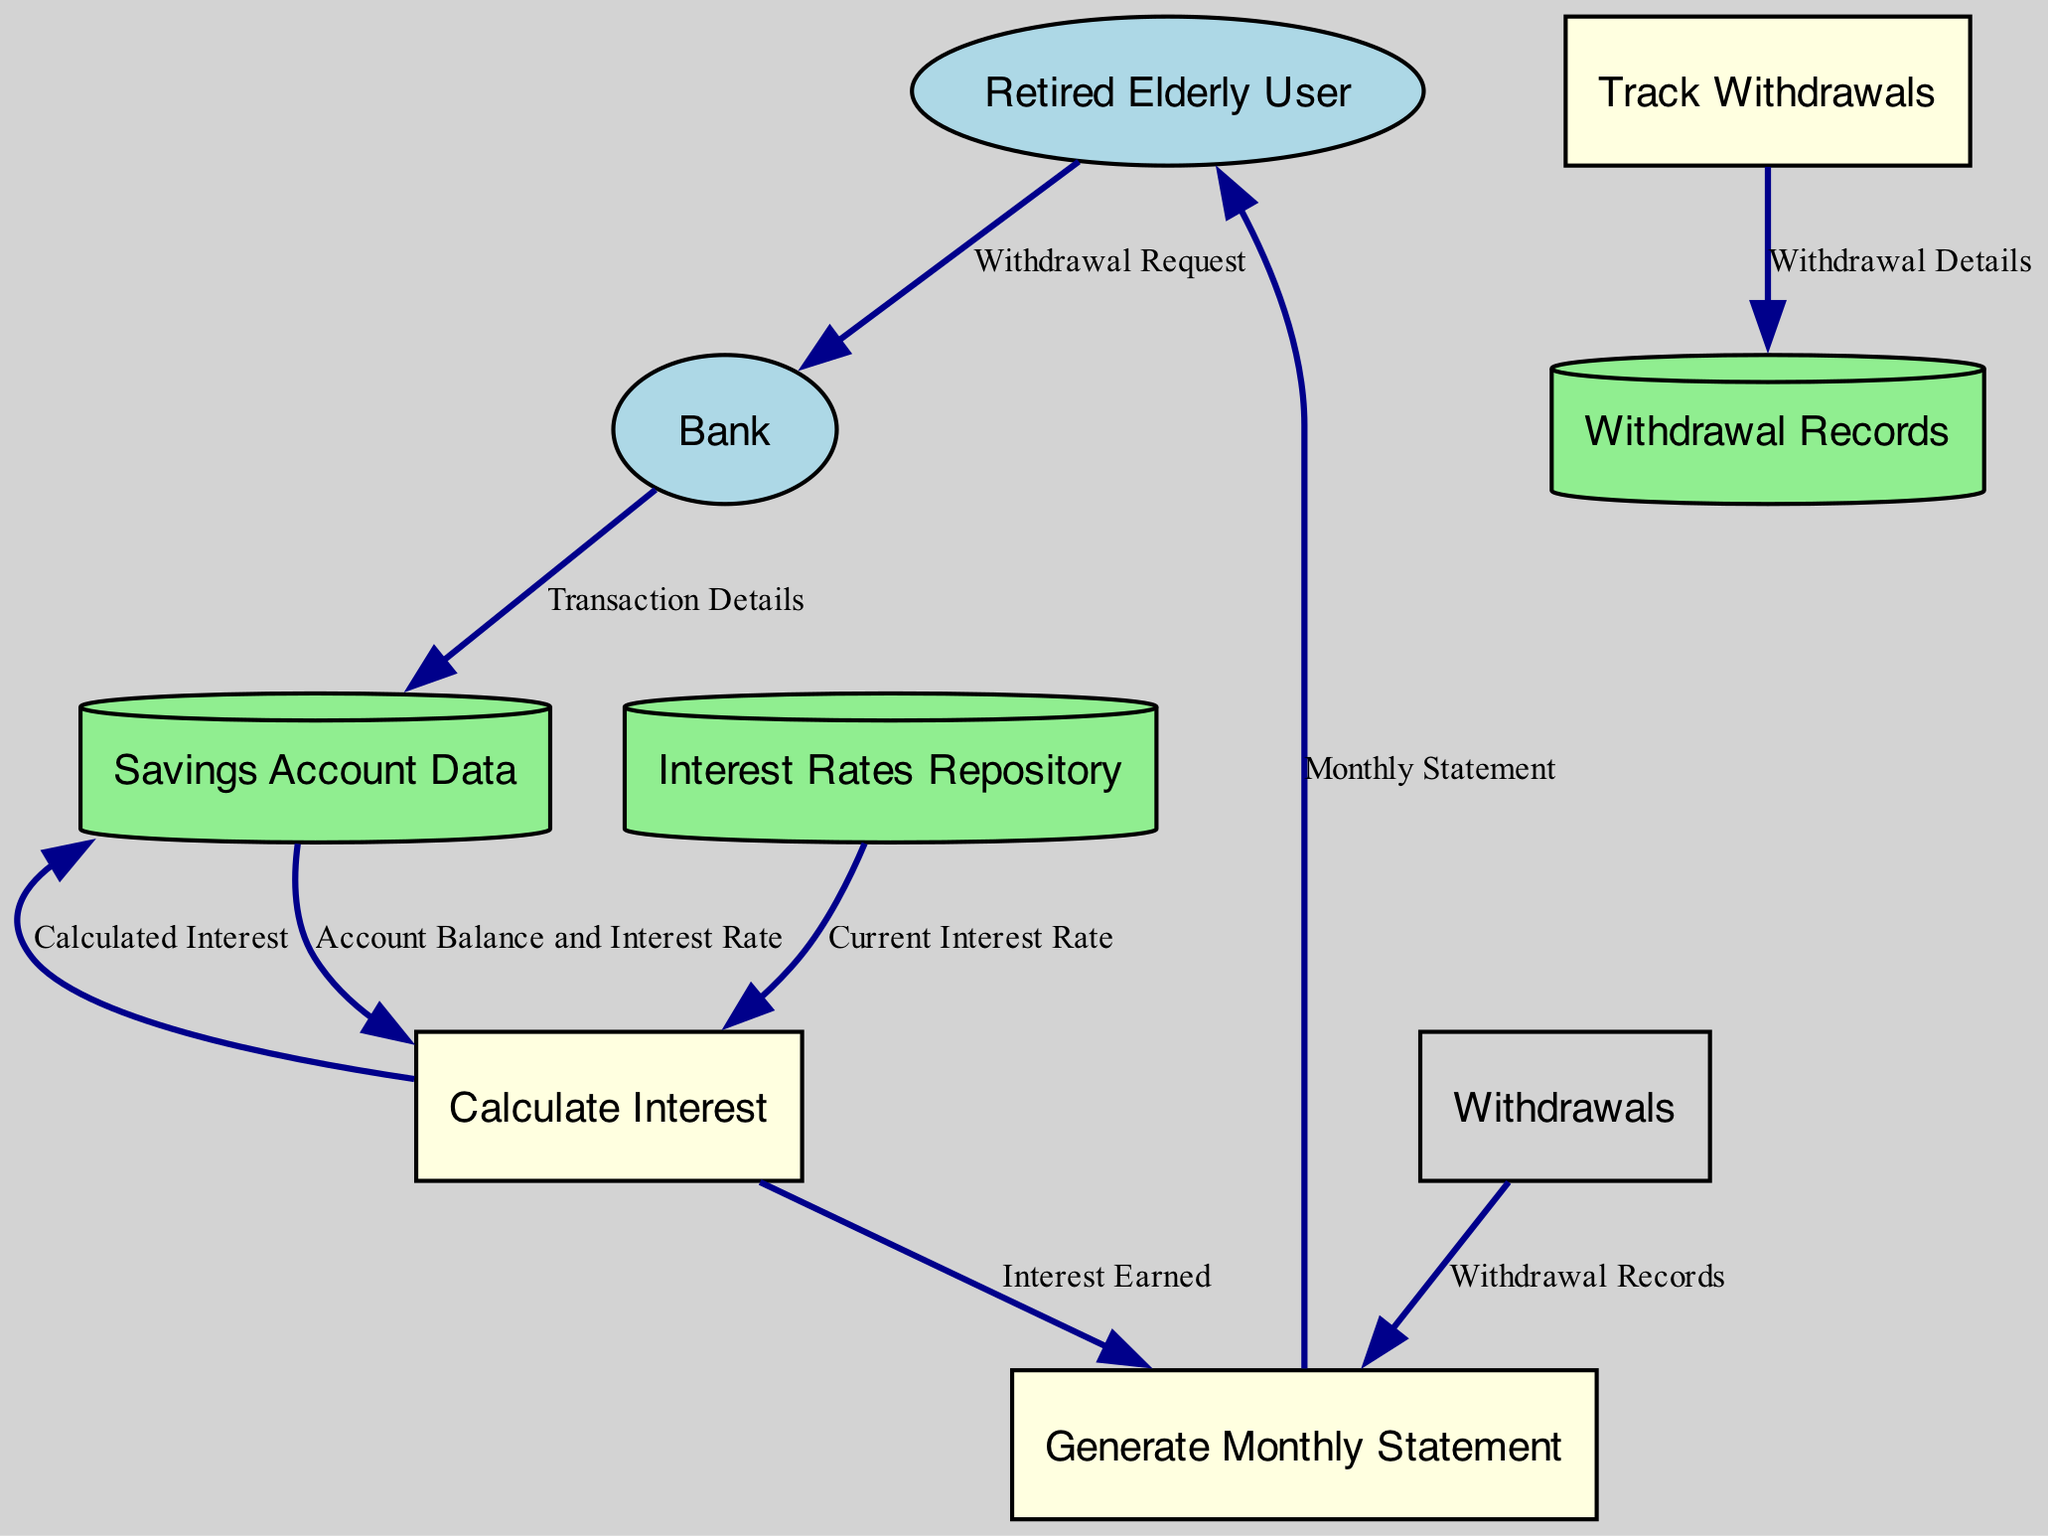What is the output from the Calculate Interest process? The output from the Calculate Interest process is the Calculated Interest. This process takes inputs from the Savings Account Data and the Interest Rates Repository, and then computes the interest based on the current balance and interest rate.
Answer: Calculated Interest How many processes are shown in the diagram? The diagram includes three processes: Calculate Interest, Track Withdrawals, and Generate Monthly Statement. This can be counted directly from the process nodes in the diagram.
Answer: Three Which entity submits a Withdrawal Request? The entity that submits a Withdrawal Request is the Retired Elderly User. This is indicated by the data flow emanating from the Retired Elderly User towards the Bank.
Answer: Retired Elderly User What data flows from Track Withdrawals to the Withdrawal Records? The data that flows from Track Withdrawals to the Withdrawal Records is the Withdrawal Details. This is shown as a data flow in the diagram outlining the connection between these two components.
Answer: Withdrawal Details What inputs are provided to the Calculate Interest process? The inputs provided to the Calculate Interest process are Account Balance and Interest Rate from the Savings Account Data, as well as the Current Interest Rate from the Interest Rates Repository. This requires analyzing the incoming flows to the Calculate Interest process.
Answer: Account Balance and Interest Rate, Current Interest Rate How many data stores are represented in the diagram? There are three data stores represented in the diagram: Savings Account Data, Interest Rates Repository, and Withdrawal Records. This can be easily identified from the data store nodes.
Answer: Three Which process generates the Monthly Statement? The Generate Monthly Statement process generates the Monthly Statement. This is the final output of the flow that includes inputs from both Calculate Interest (providing Interest Earned) and Withdrawal Records.
Answer: Generate Monthly Statement What information does the Monthly Statement contain? The Monthly Statement contains Information regarding Interest Earned and Withdrawal Records. This is inferred from the data flows leading into the Generate Monthly Statement process and what it outputs.
Answer: Interest Earned and Withdrawal Records 